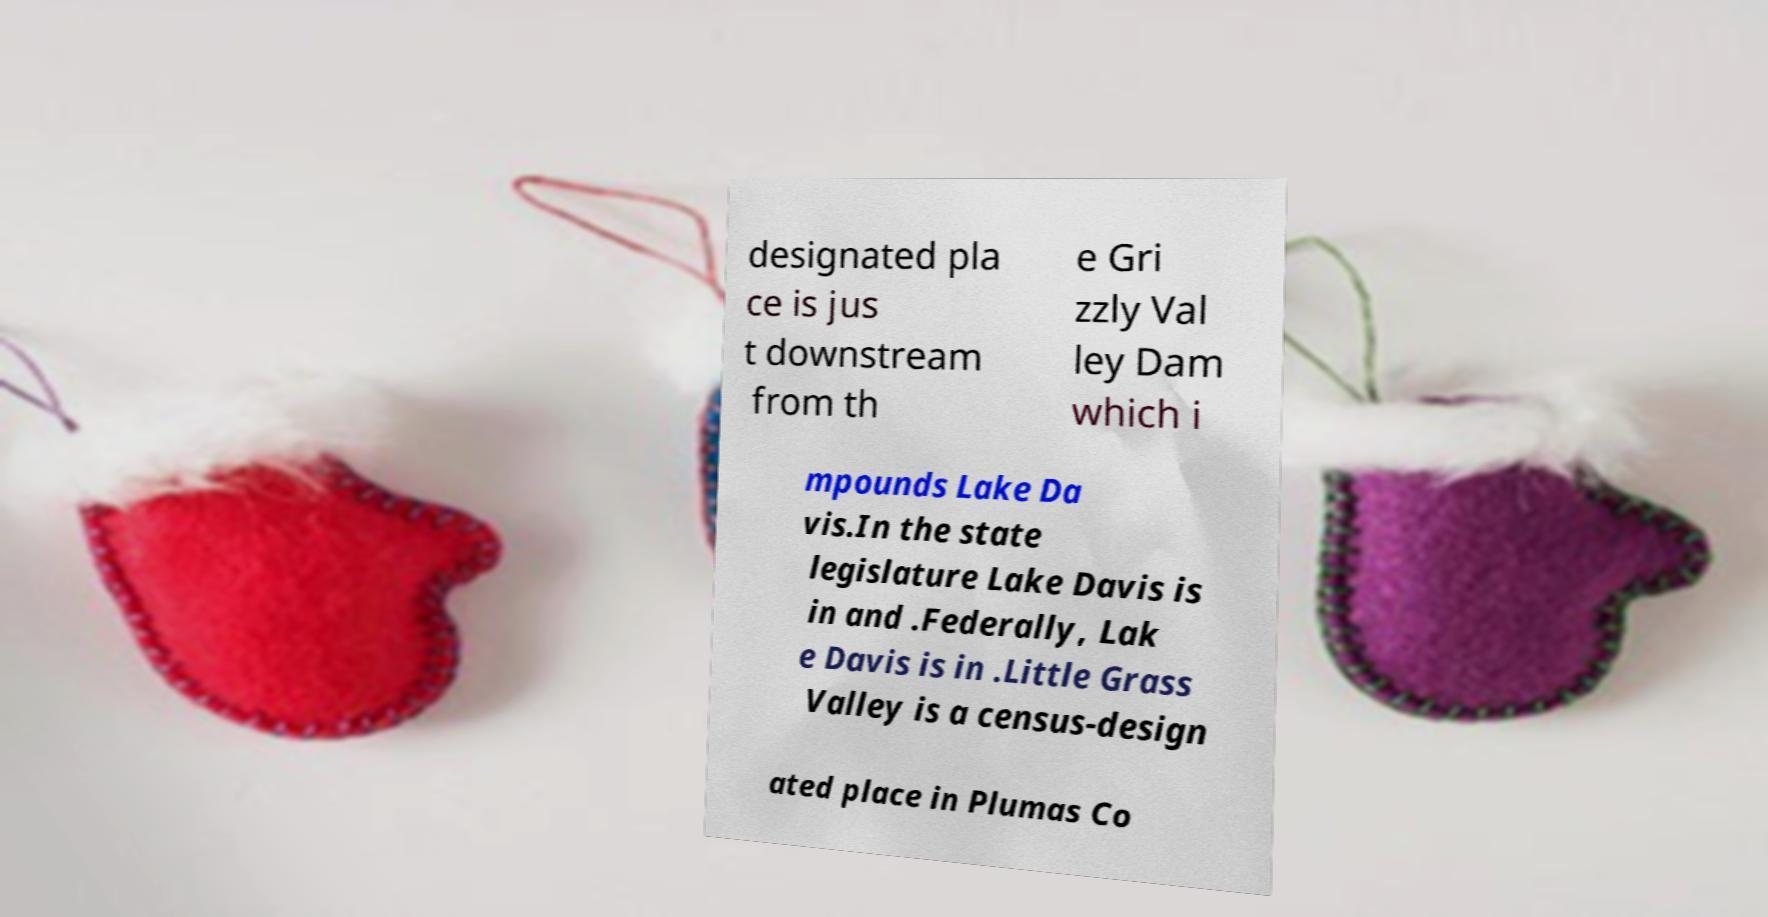There's text embedded in this image that I need extracted. Can you transcribe it verbatim? designated pla ce is jus t downstream from th e Gri zzly Val ley Dam which i mpounds Lake Da vis.In the state legislature Lake Davis is in and .Federally, Lak e Davis is in .Little Grass Valley is a census-design ated place in Plumas Co 